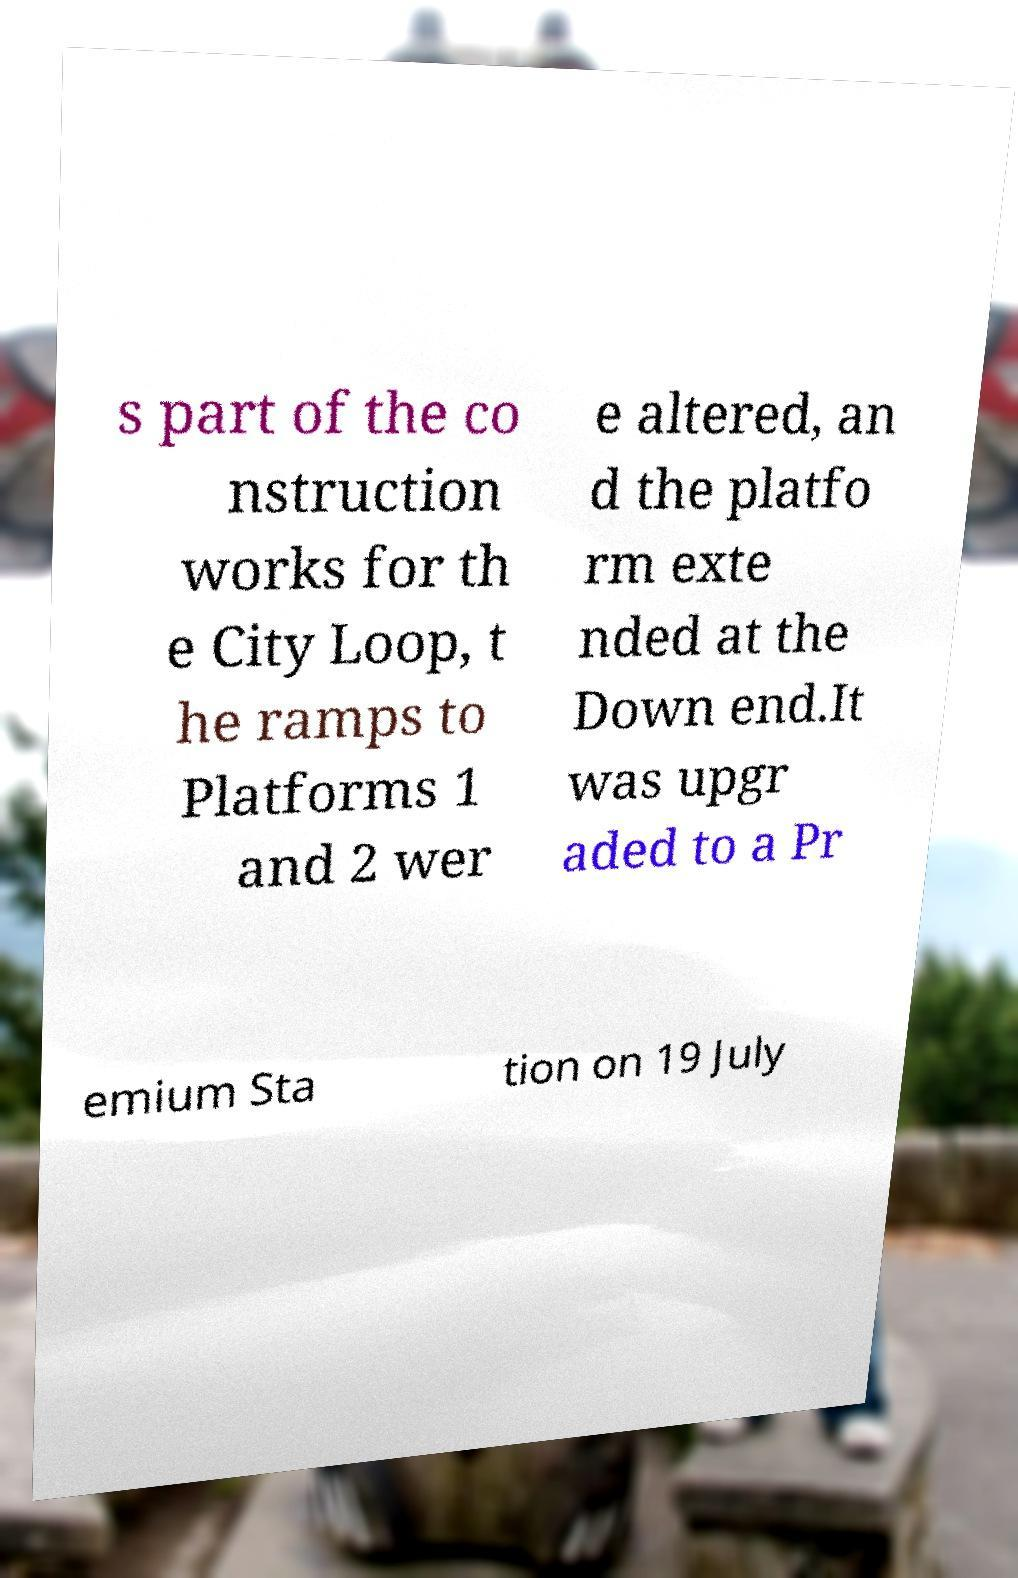For documentation purposes, I need the text within this image transcribed. Could you provide that? s part of the co nstruction works for th e City Loop, t he ramps to Platforms 1 and 2 wer e altered, an d the platfo rm exte nded at the Down end.It was upgr aded to a Pr emium Sta tion on 19 July 